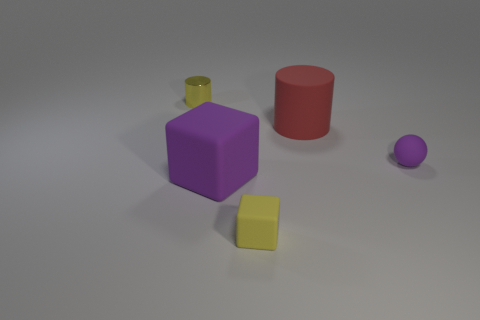Is the material of the yellow cylinder the same as the yellow object in front of the metallic thing?
Offer a very short reply. No. There is a big rubber thing left of the yellow object in front of the small yellow thing that is behind the purple rubber ball; what color is it?
Provide a short and direct response. Purple. Is there anything else that has the same shape as the large red rubber thing?
Provide a succinct answer. Yes. Is the number of small yellow blocks greater than the number of blocks?
Give a very brief answer. No. How many objects are both right of the big cylinder and on the left side of the large cylinder?
Your response must be concise. 0. There is a object to the left of the purple cube; what number of large purple objects are right of it?
Offer a terse response. 1. Is the size of the purple thing that is left of the ball the same as the yellow object that is in front of the tiny metallic object?
Your answer should be very brief. No. How many matte spheres are there?
Your answer should be very brief. 1. What number of other cylinders are made of the same material as the small cylinder?
Ensure brevity in your answer.  0. Are there an equal number of large red cylinders that are on the left side of the tiny yellow cube and purple matte blocks?
Your answer should be very brief. No. 